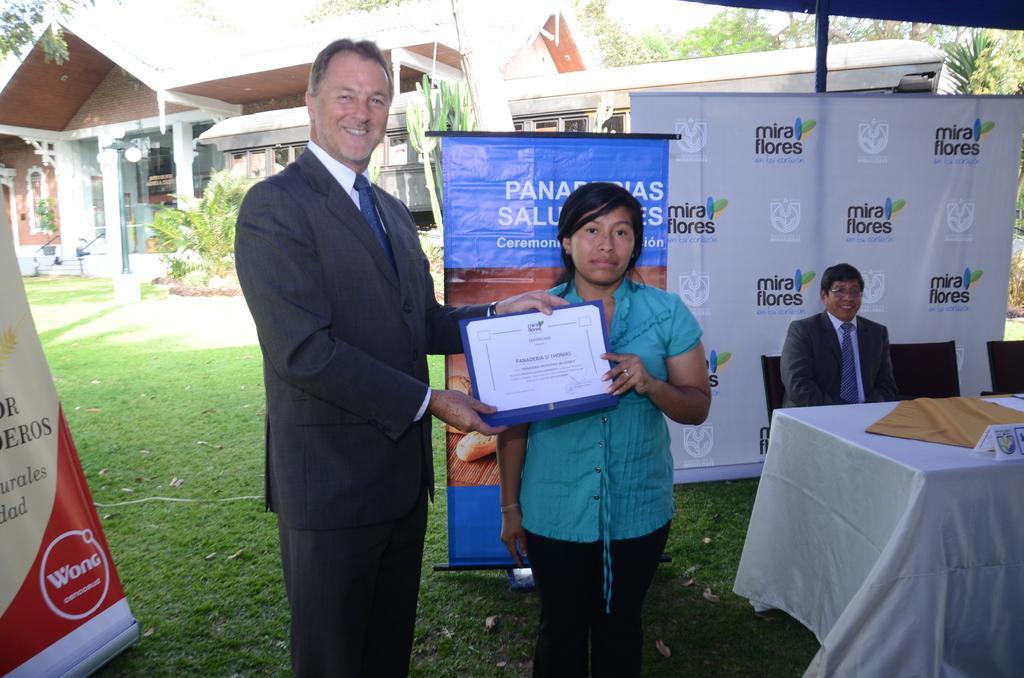Can you describe this image briefly? In this image a man is giving a certificate to a lady. The man is smiling. here another person is sitting on chair. He is smiling. In front of him there is a table. There are banners here. In the background there are trees and building. 